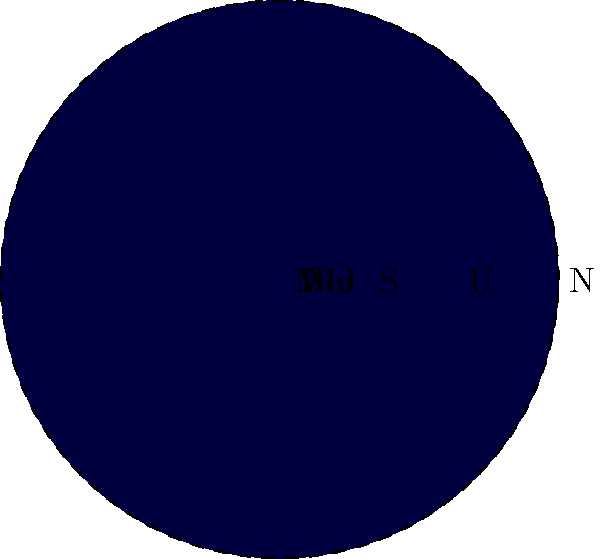In the context of international humanitarian law, understanding scale and proportion is crucial. This principle applies to both planetary bodies and the scope of armed conflicts. Given the diagram showing the relative sizes of planets in our solar system, which planet's size is most disproportionate to its potential impact on interplanetary relations, similar to how a small state might have a significant influence in international law? To answer this question, we need to consider both the size and potential impact of each planet:

1. Mercury (Me): Smallest planet, closest to the Sun, but limited impact.
2. Venus (V): Similar size to Earth, but inhospitable conditions limit its relevance.
3. Earth (E): Our home planet, significant due to human presence.
4. Mars (Ma): Smaller than Earth, but of interest for potential colonization.
5. Jupiter (J): Largest planet, significant gravitational influence.
6. Saturn (S): Second-largest, known for its rings.
7. Uranus (U): Ice giant, less prominent in planetary studies.
8. Neptune (N): Furthest planet, less studied but influential in solar system dynamics.

Despite its small size, Mars (Ma) has a disproportionate impact on interplanetary relations and future space exploration efforts. This is analogous to how a small state might have significant influence in international humanitarian law discussions, particularly in areas like the laws of war and reparations.

Mars is much smaller than the gas giants (Jupiter, Saturn, Uranus, Neptune) and even Earth, yet it holds immense potential for future human exploration and possibly colonization. This makes it disproportionately important in discussions about the future of human space presence and potential interplanetary relations.

In the context of international law, this is similar to how a small state might become central to discussions on the laws of war or reparations due to its unique experiences or strategic importance, despite its size or apparent power on the global stage.
Answer: Mars 